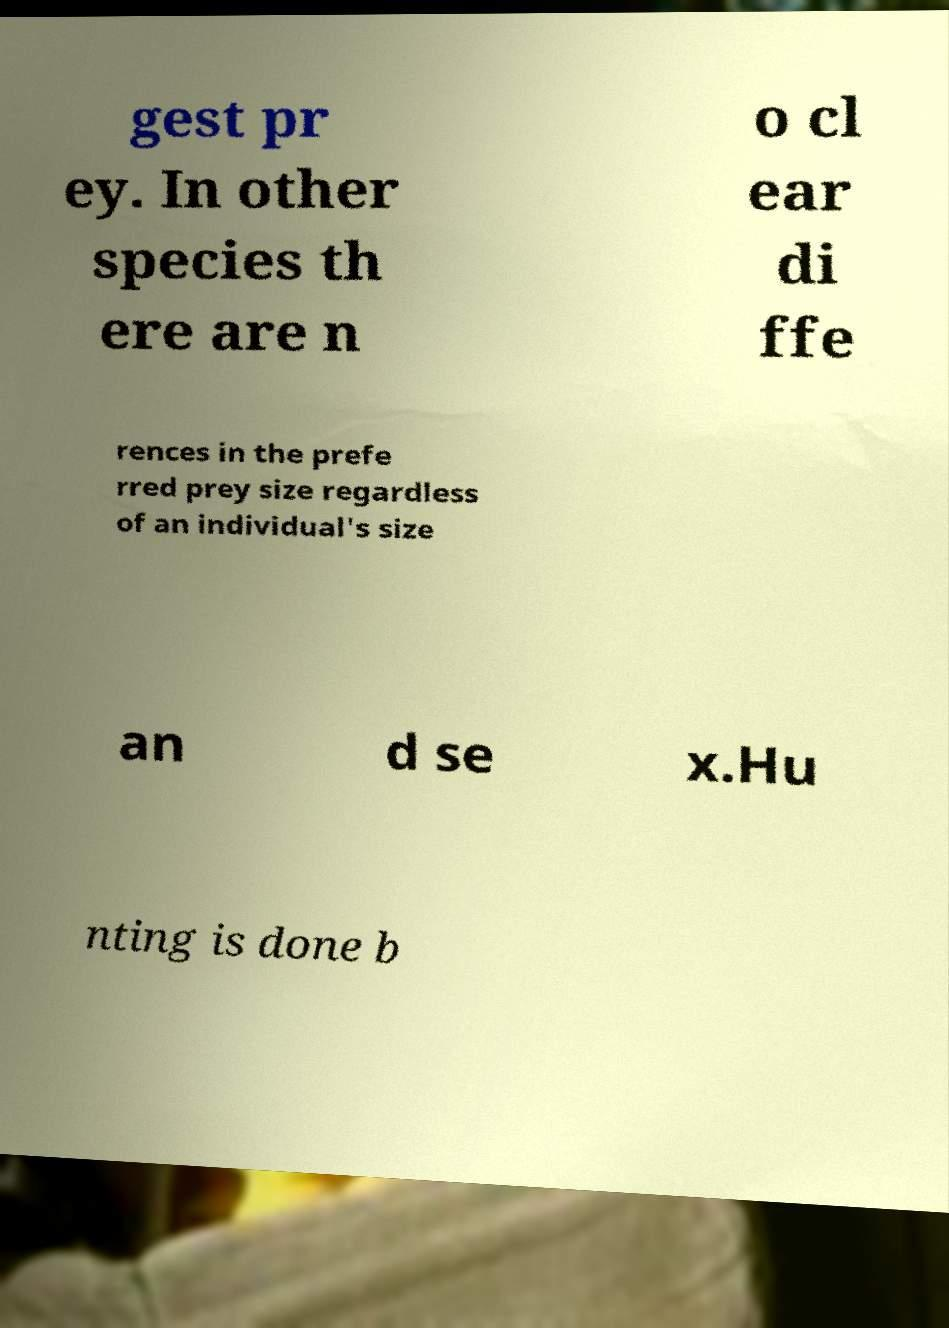Could you assist in decoding the text presented in this image and type it out clearly? gest pr ey. In other species th ere are n o cl ear di ffe rences in the prefe rred prey size regardless of an individual's size an d se x.Hu nting is done b 